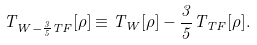Convert formula to latex. <formula><loc_0><loc_0><loc_500><loc_500>T _ { W - \frac { 3 } { 5 } T F } [ \rho ] \equiv T _ { W } [ \rho ] - \frac { 3 } { 5 } T _ { T F } [ \rho ] .</formula> 